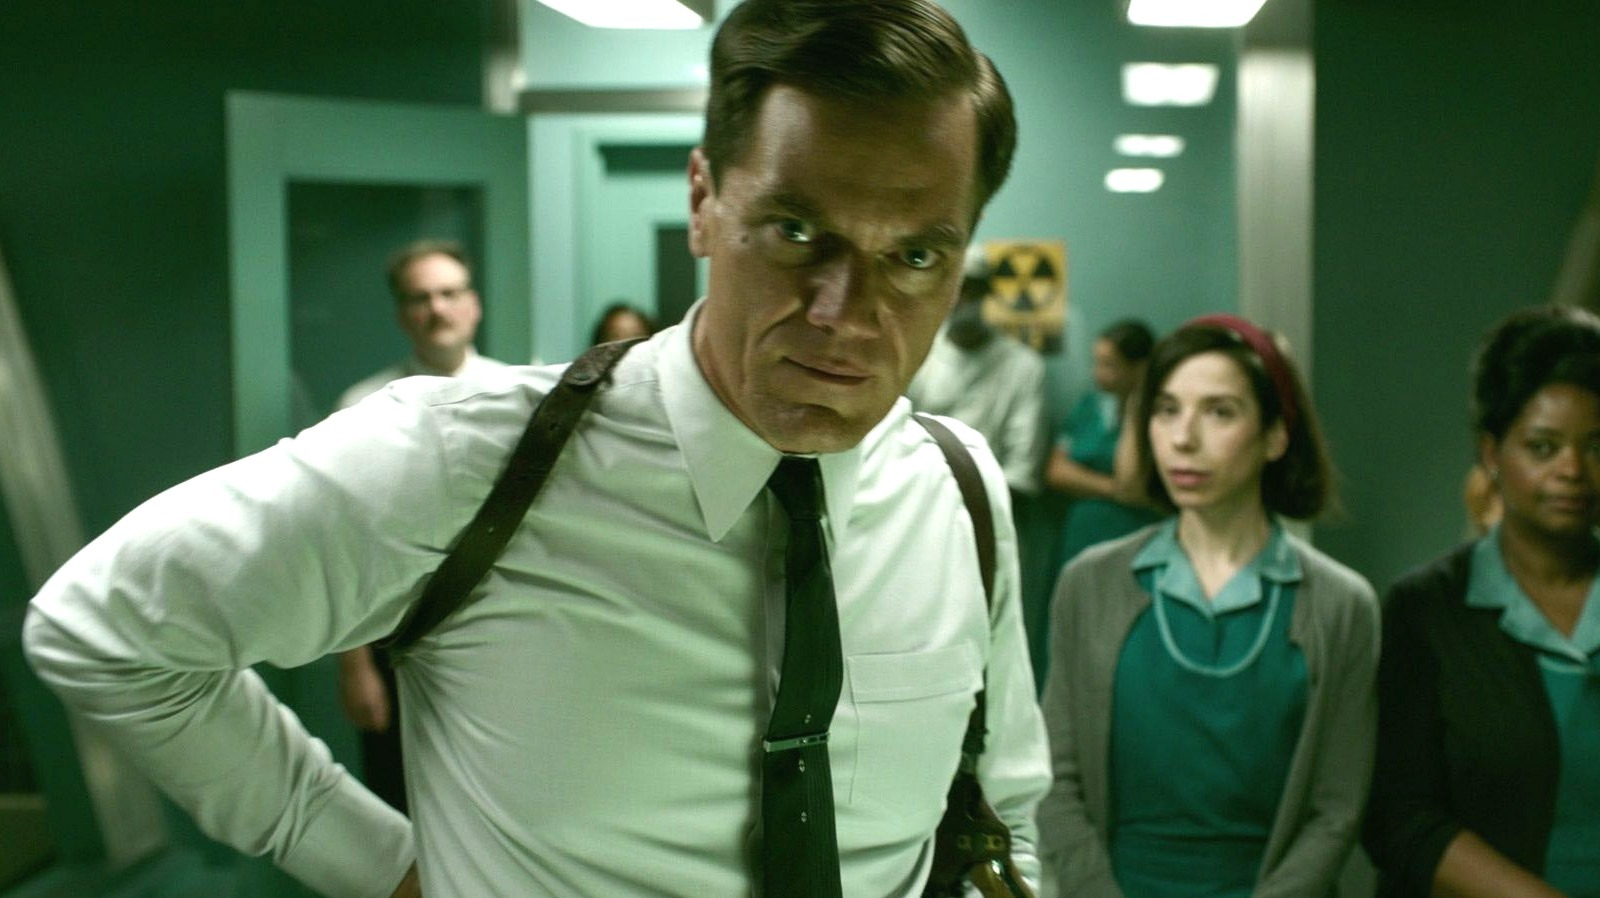What do you think is going on in this snapshot? This image depicts a tense scene set in a hospital or medical setting. The man in the foreground, dressed in a white shirt with black suspenders and tie, conveys a grave and determined attitude, hinting at a serious situation or confrontation. His hands rest on his hips, and he stands slightly leaned forward, focusing intently off to the side. The background features a diverse group of individuals in various medical or hospital uniforms, reflecting a busy workplace environment. The subdued green and white color palette, along with the facial expressions and posture of the characters, add to the overall atmosphere of urgency and concern. 